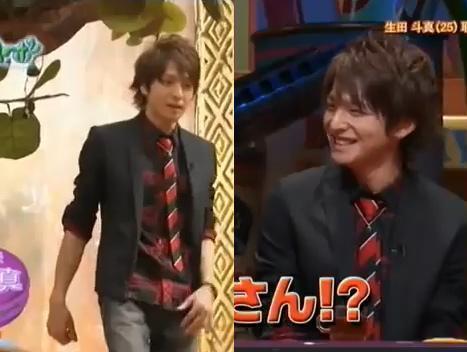How many pictures are shown here?
Give a very brief answer. 2. How many people are in the photo?
Give a very brief answer. 2. How many birds are in the picture?
Give a very brief answer. 0. 